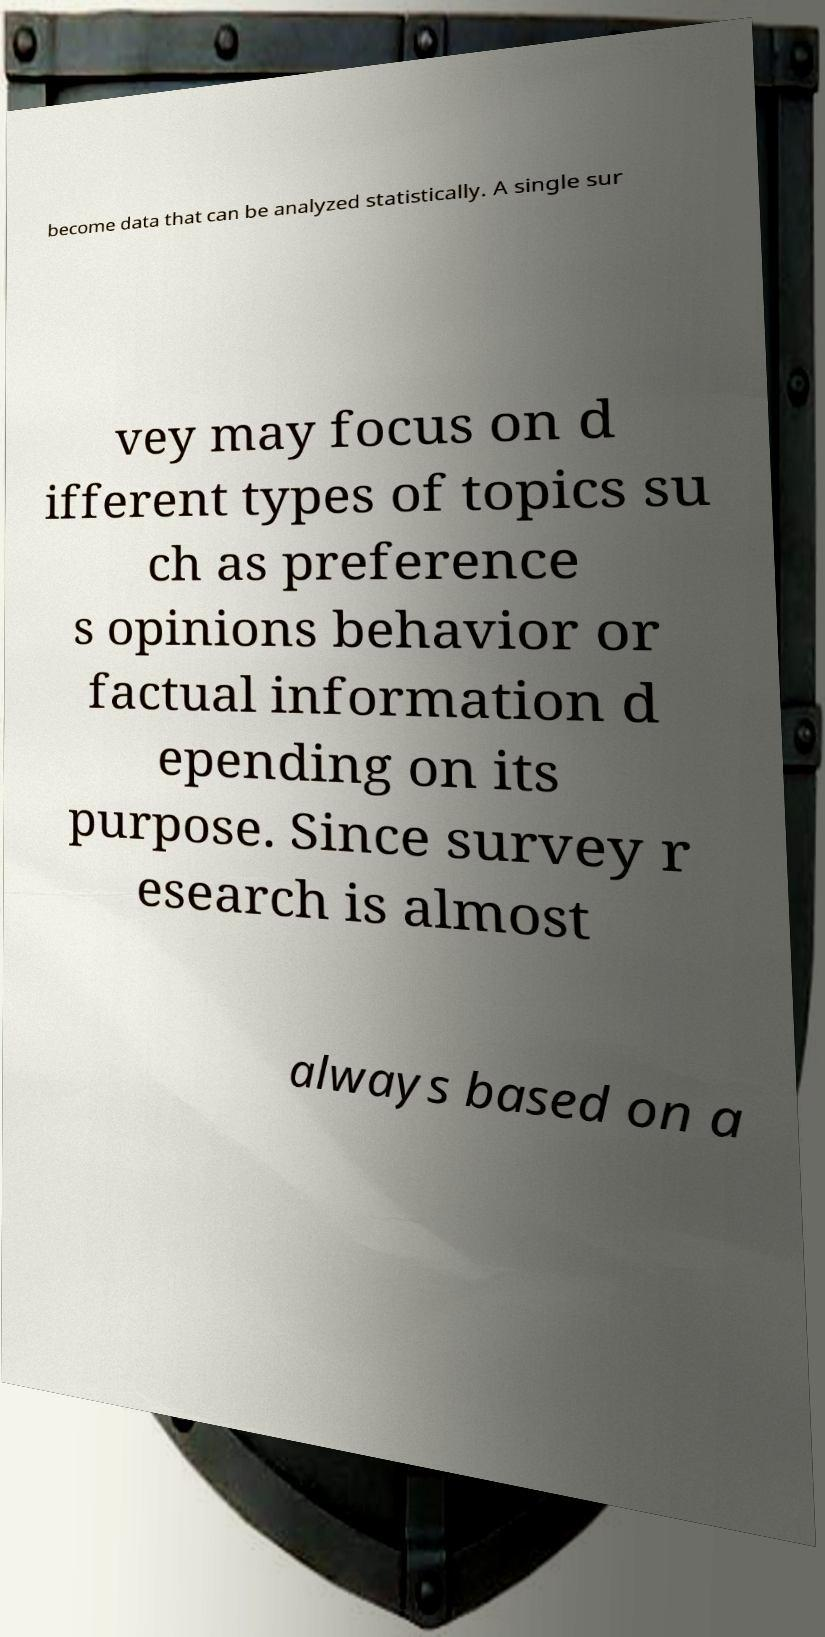Can you accurately transcribe the text from the provided image for me? become data that can be analyzed statistically. A single sur vey may focus on d ifferent types of topics su ch as preference s opinions behavior or factual information d epending on its purpose. Since survey r esearch is almost always based on a 